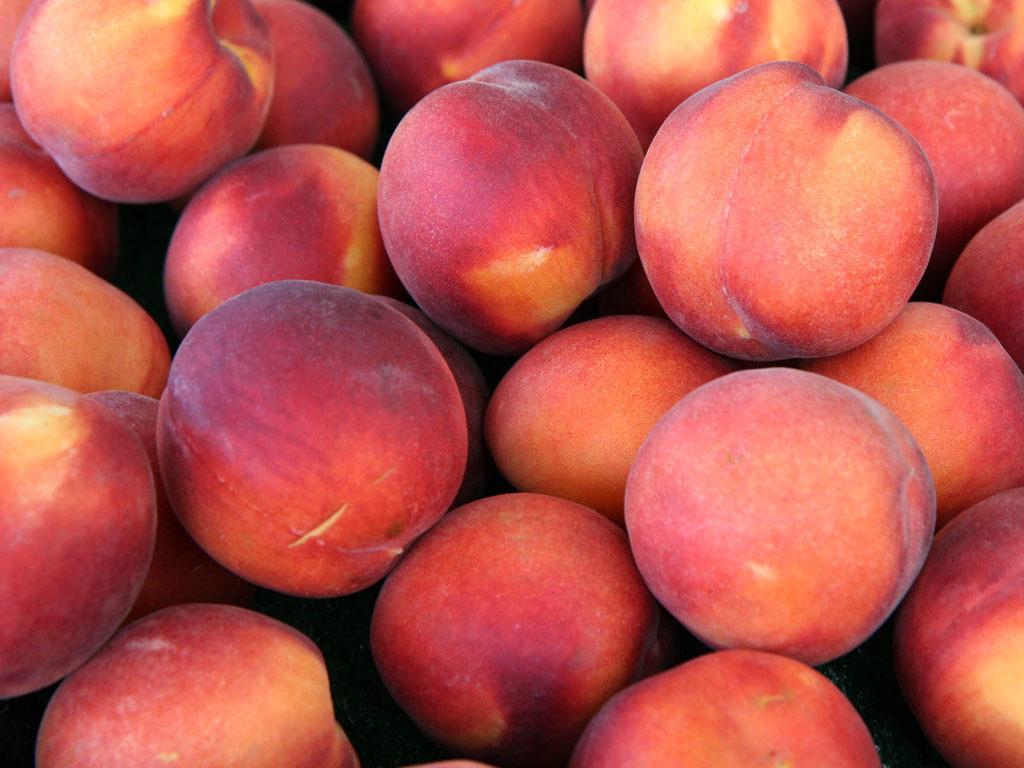How would you summarize this image in a sentence or two? In this picture we can see a group of apples. 